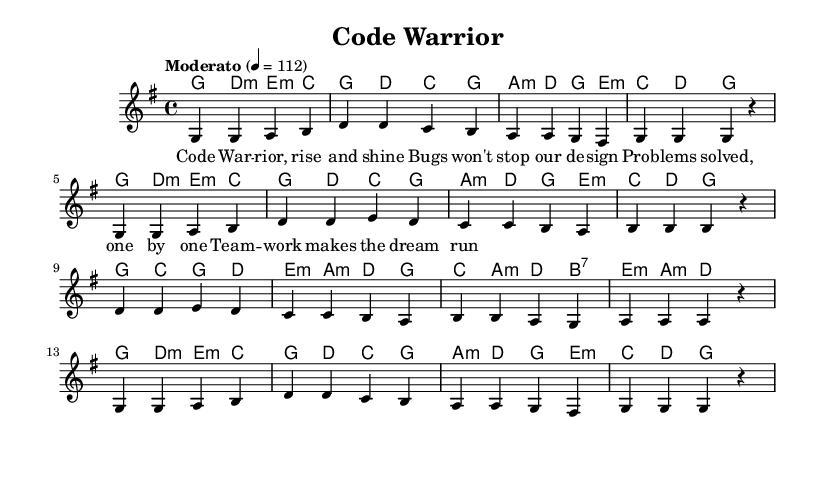What is the key signature of this music? The key signature is G major, which has one sharp (F#).
Answer: G major What is the time signature of this piece? The time signature is 4/4, indicating four beats per measure.
Answer: 4/4 What is the tempo of the piece? The tempo marking indicates "Moderato" with a metronome marking of 112 beats per minute.
Answer: Moderato 112 How many measures are in the melody? The melody has 16 measures, as counted from the music staff.
Answer: 16 What is the first lyric line of the piece? The first lyric line is "Code Warrior, rise and shine," which can be found at the start of the lyrics.
Answer: Code Warrior, rise and shine What type of chords are predominantly used in this piece? The chords include major and minor chords, prominently featuring G major, D minor, and A minor.
Answer: Major and minor chords How does the lyrics structure reflect typical pop song patterns? The lyrics follow a repetitive structure and positive themes, common in pop songs that emphasize motivation and teamwork.
Answer: Repetitive structure and positive themes 